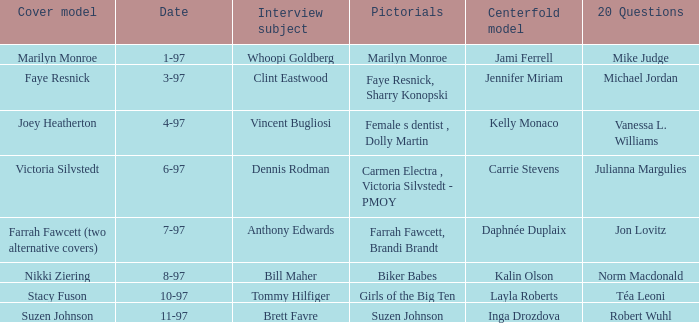When was Kalin Olson listed as  the centerfold model? 8-97. 